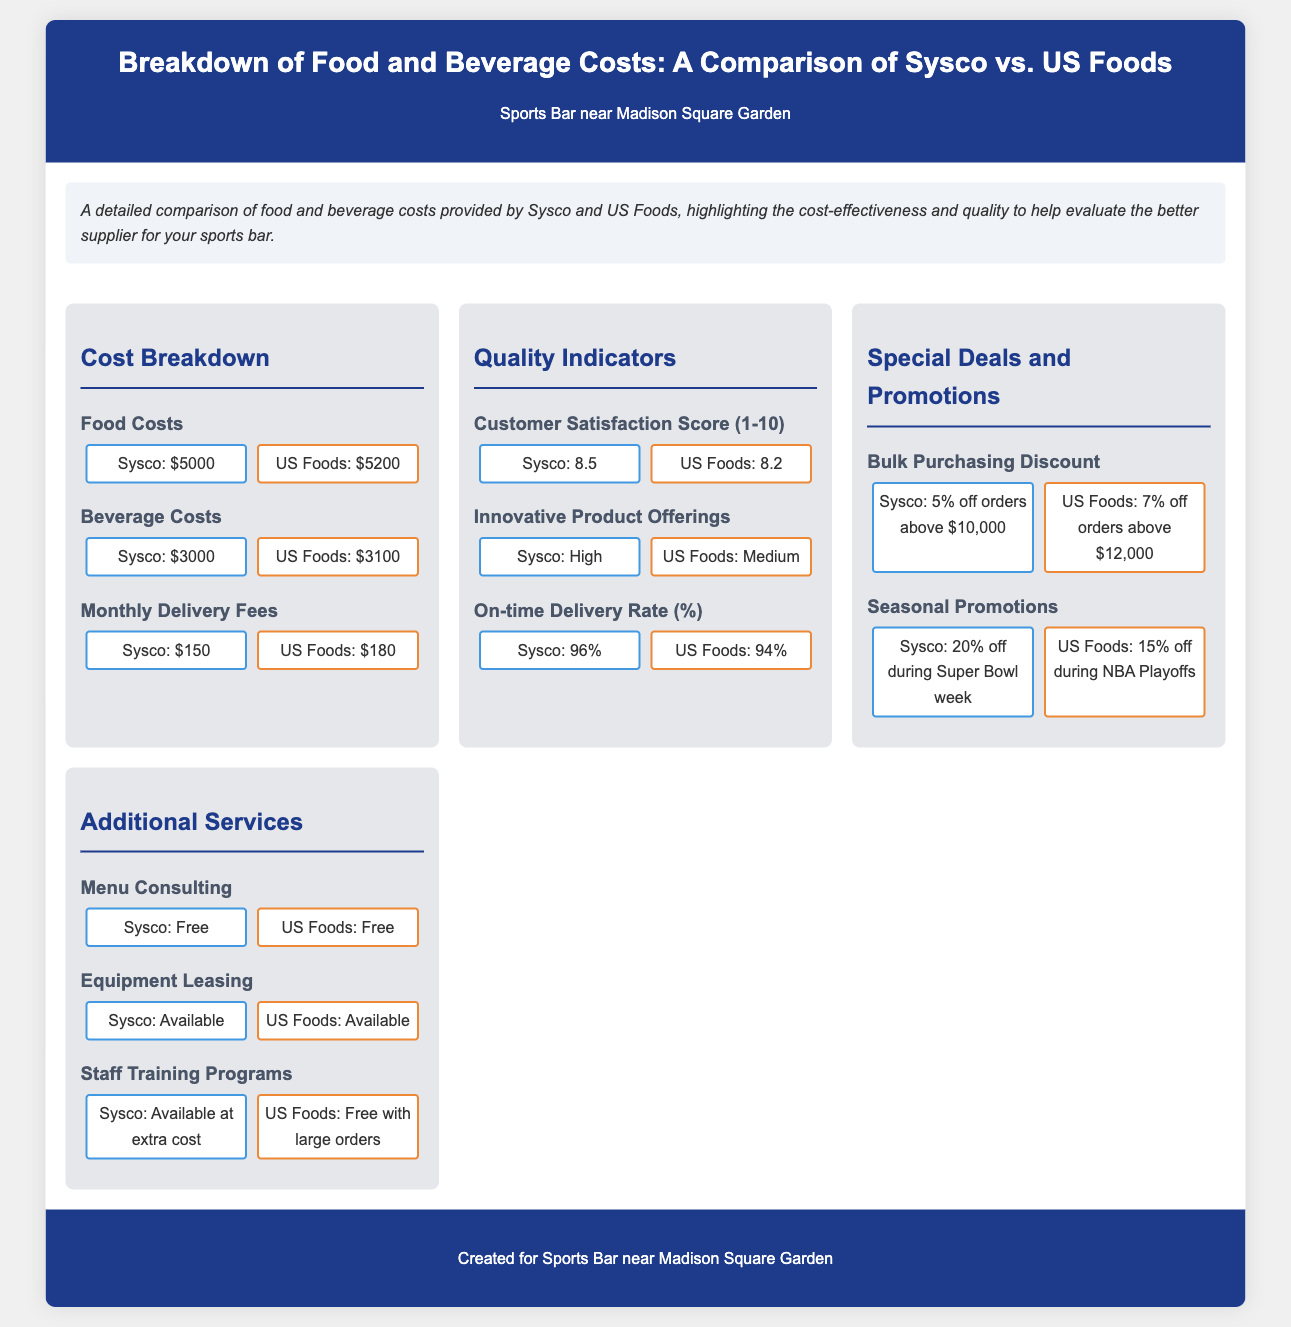What is the food cost of Sysco? The food cost provided by Sysco in the document is $5000.
Answer: $5000 What is the beverage cost of US Foods? The beverage cost listed for US Foods in the document is $3100.
Answer: $3100 Which supplier has a higher customer satisfaction score? The document shows Sysco with a customer satisfaction score of 8.5, higher than US Foods' score of 8.2.
Answer: Sysco What is the on-time delivery rate for Sysco? The on-time delivery rate for Sysco is noted as 96% in the document.
Answer: 96% Which supplier offers a greater bulk purchasing discount? The document specifies that US Foods offers a 7% discount, greater than Sysco's 5%.
Answer: US Foods What is the total cost of beverage and food combined for Sysco? The total cost for Sysco is calculated as food costs of $5000 plus beverage costs of $3000, totaling $8000.
Answer: $8000 Is menu consulting offered by both suppliers? The document states that both suppliers, Sysco and US Foods, offer menu consulting for free.
Answer: Yes Which supplier provides staff training programs for free? According to the document, US Foods offers staff training programs for free with large orders, while Sysco charges extra.
Answer: US Foods 